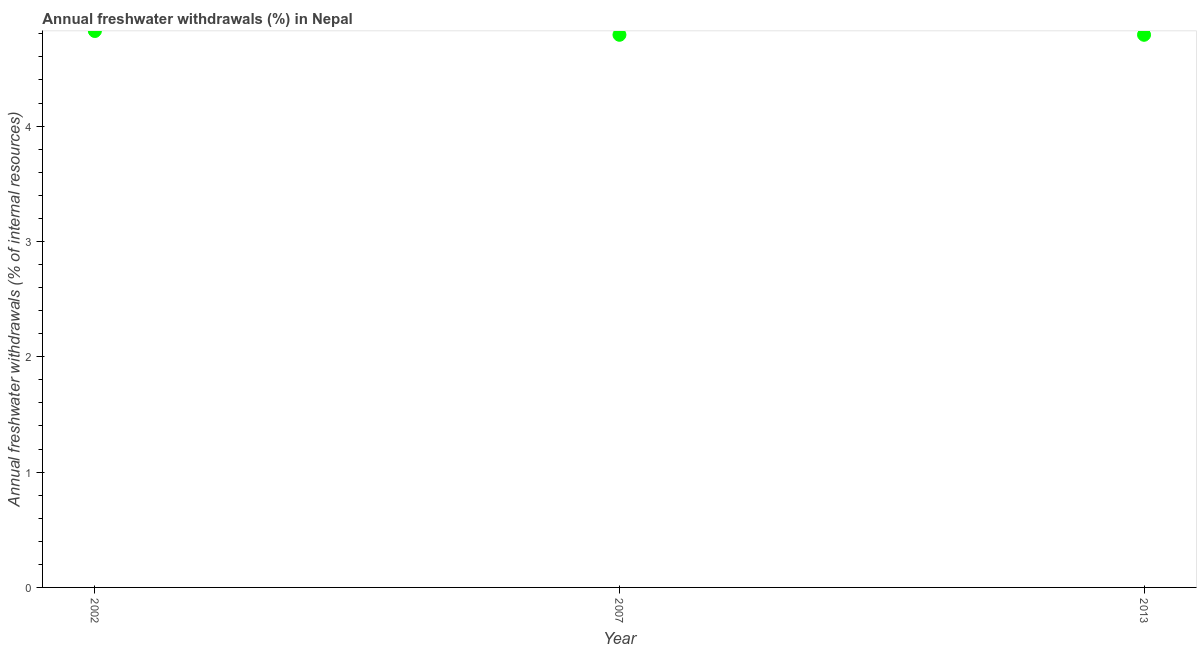What is the annual freshwater withdrawals in 2007?
Offer a terse response. 4.79. Across all years, what is the maximum annual freshwater withdrawals?
Your response must be concise. 4.82. Across all years, what is the minimum annual freshwater withdrawals?
Provide a succinct answer. 4.79. In which year was the annual freshwater withdrawals maximum?
Provide a short and direct response. 2002. In which year was the annual freshwater withdrawals minimum?
Make the answer very short. 2007. What is the sum of the annual freshwater withdrawals?
Your answer should be compact. 14.41. What is the difference between the annual freshwater withdrawals in 2002 and 2013?
Your answer should be very brief. 0.03. What is the average annual freshwater withdrawals per year?
Your answer should be compact. 4.8. What is the median annual freshwater withdrawals?
Your response must be concise. 4.79. In how many years, is the annual freshwater withdrawals greater than 2.8 %?
Provide a short and direct response. 3. Do a majority of the years between 2013 and 2007 (inclusive) have annual freshwater withdrawals greater than 4.6 %?
Offer a terse response. No. What is the ratio of the annual freshwater withdrawals in 2002 to that in 2013?
Your answer should be very brief. 1.01. Is the annual freshwater withdrawals in 2002 less than that in 2007?
Give a very brief answer. No. Is the difference between the annual freshwater withdrawals in 2007 and 2013 greater than the difference between any two years?
Offer a terse response. No. What is the difference between the highest and the second highest annual freshwater withdrawals?
Offer a terse response. 0.03. Is the sum of the annual freshwater withdrawals in 2002 and 2013 greater than the maximum annual freshwater withdrawals across all years?
Provide a short and direct response. Yes. What is the difference between the highest and the lowest annual freshwater withdrawals?
Provide a succinct answer. 0.03. How many dotlines are there?
Provide a short and direct response. 1. How many years are there in the graph?
Offer a terse response. 3. What is the difference between two consecutive major ticks on the Y-axis?
Provide a short and direct response. 1. Does the graph contain any zero values?
Provide a succinct answer. No. What is the title of the graph?
Give a very brief answer. Annual freshwater withdrawals (%) in Nepal. What is the label or title of the Y-axis?
Provide a succinct answer. Annual freshwater withdrawals (% of internal resources). What is the Annual freshwater withdrawals (% of internal resources) in 2002?
Ensure brevity in your answer.  4.82. What is the Annual freshwater withdrawals (% of internal resources) in 2007?
Make the answer very short. 4.79. What is the Annual freshwater withdrawals (% of internal resources) in 2013?
Keep it short and to the point. 4.79. What is the difference between the Annual freshwater withdrawals (% of internal resources) in 2002 and 2007?
Make the answer very short. 0.03. What is the difference between the Annual freshwater withdrawals (% of internal resources) in 2002 and 2013?
Keep it short and to the point. 0.03. What is the difference between the Annual freshwater withdrawals (% of internal resources) in 2007 and 2013?
Provide a short and direct response. 0. What is the ratio of the Annual freshwater withdrawals (% of internal resources) in 2002 to that in 2007?
Offer a very short reply. 1.01. What is the ratio of the Annual freshwater withdrawals (% of internal resources) in 2002 to that in 2013?
Offer a very short reply. 1.01. What is the ratio of the Annual freshwater withdrawals (% of internal resources) in 2007 to that in 2013?
Your answer should be compact. 1. 